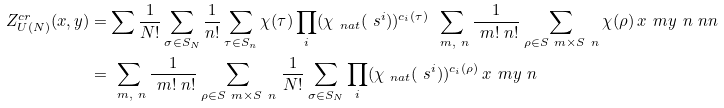Convert formula to latex. <formula><loc_0><loc_0><loc_500><loc_500>Z ^ { c r } _ { U ( N ) } ( x , y ) & = \sum _ { \L } \frac { 1 } { N ! } \sum _ { \sigma \in S _ { N } } \frac { 1 } { n ! } \sum _ { \tau \in S _ { n } } \chi _ { \L } ( \tau ) \prod _ { i } ( \chi _ { \ n a t } ( \ s ^ { i } ) ) ^ { c _ { i } ( \tau ) } \, \sum _ { \ m , \ n } \frac { 1 } { \ m ! \ n ! } \sum _ { \rho \in S _ { \ } m \times S _ { \ } n } \chi _ { \L } ( \rho ) \, x ^ { \ } m y ^ { \ } n \ n n \\ & = \sum _ { \ m , \ n } \frac { 1 } { \ m ! \ n ! } \sum _ { \rho \in S _ { \ } m \times S _ { \ } n } \, \frac { 1 } { N ! } \sum _ { \sigma \in S _ { N } } \prod _ { i } ( \chi _ { \ n a t } ( \ s ^ { i } ) ) ^ { c _ { i } ( \rho ) } \, x ^ { \ } m y ^ { \ } n</formula> 